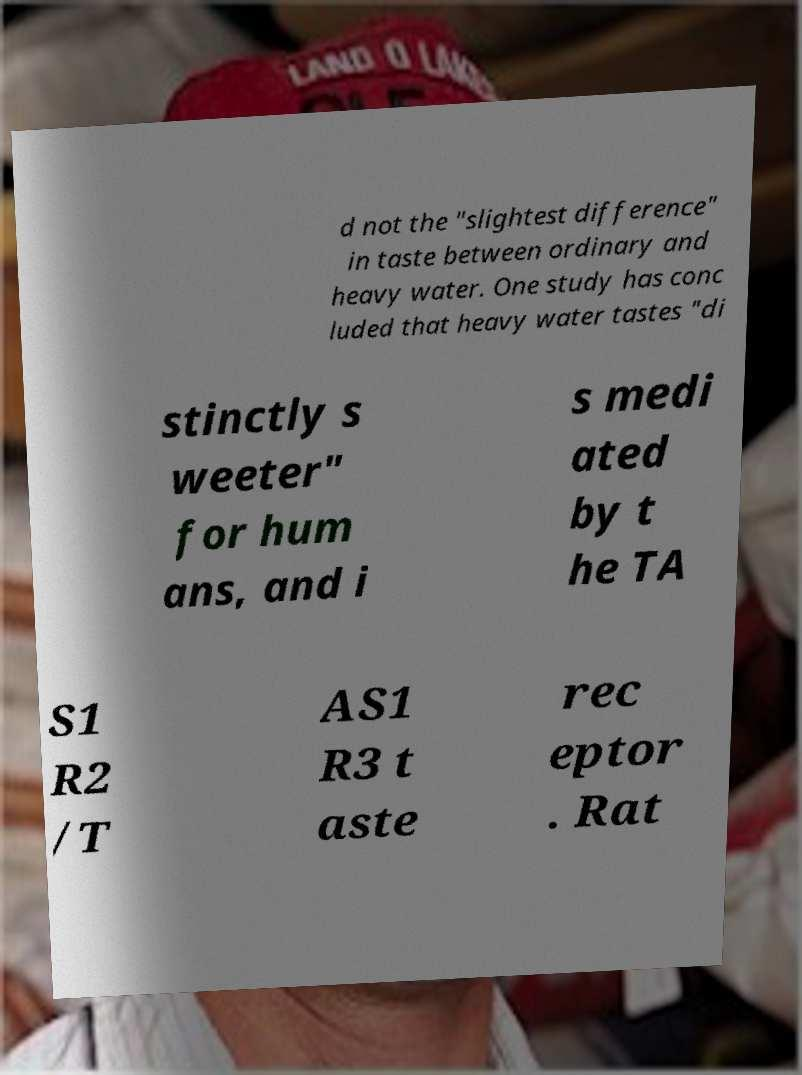Could you extract and type out the text from this image? d not the "slightest difference" in taste between ordinary and heavy water. One study has conc luded that heavy water tastes "di stinctly s weeter" for hum ans, and i s medi ated by t he TA S1 R2 /T AS1 R3 t aste rec eptor . Rat 